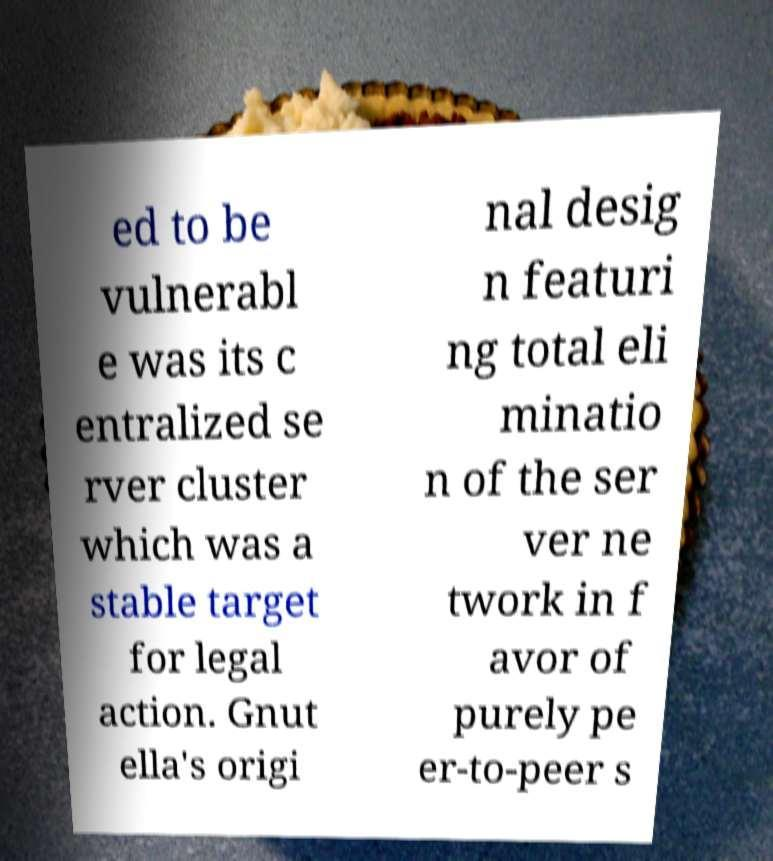For documentation purposes, I need the text within this image transcribed. Could you provide that? ed to be vulnerabl e was its c entralized se rver cluster which was a stable target for legal action. Gnut ella's origi nal desig n featuri ng total eli minatio n of the ser ver ne twork in f avor of purely pe er-to-peer s 